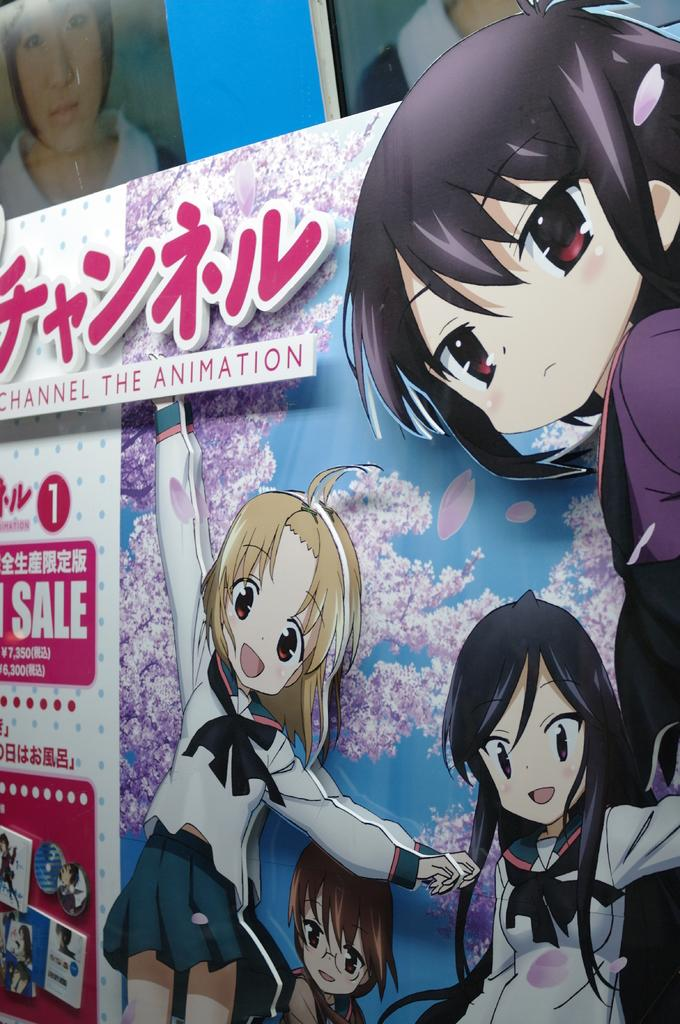What is depicted on the poster in the image? There is a poster with animated character images in the image. What else can be seen on the poster besides the images? There is text written on the poster. What can be seen in the background of the image? There are photos of people in the background. What type of apparatus is being used by the person in the image? There is no person or apparatus present in the image; it only features a poster with animated character images and text, as well as photos of people in the background. 